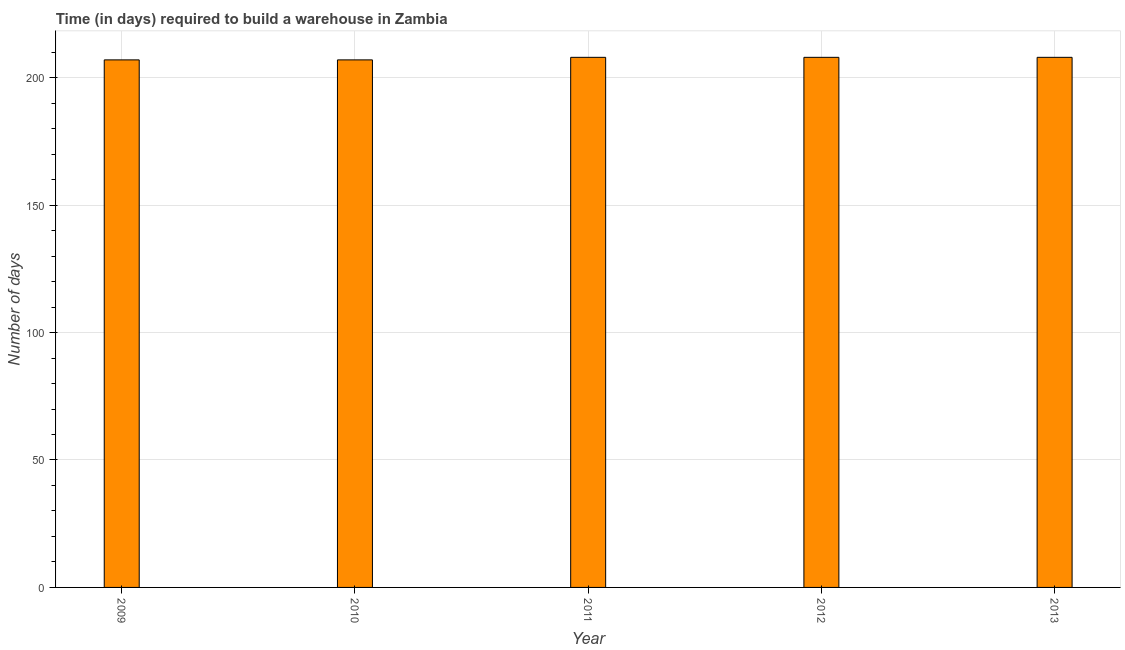What is the title of the graph?
Offer a terse response. Time (in days) required to build a warehouse in Zambia. What is the label or title of the Y-axis?
Your answer should be compact. Number of days. What is the time required to build a warehouse in 2010?
Offer a very short reply. 207. Across all years, what is the maximum time required to build a warehouse?
Keep it short and to the point. 208. Across all years, what is the minimum time required to build a warehouse?
Provide a succinct answer. 207. In which year was the time required to build a warehouse maximum?
Make the answer very short. 2011. What is the sum of the time required to build a warehouse?
Your answer should be very brief. 1038. What is the difference between the time required to build a warehouse in 2009 and 2010?
Provide a short and direct response. 0. What is the average time required to build a warehouse per year?
Provide a short and direct response. 207. What is the median time required to build a warehouse?
Your answer should be compact. 208. Do a majority of the years between 2009 and 2012 (inclusive) have time required to build a warehouse greater than 40 days?
Your response must be concise. Yes. Is the time required to build a warehouse in 2009 less than that in 2013?
Offer a terse response. Yes. Is the difference between the time required to build a warehouse in 2011 and 2013 greater than the difference between any two years?
Your answer should be compact. No. In how many years, is the time required to build a warehouse greater than the average time required to build a warehouse taken over all years?
Provide a succinct answer. 3. How many bars are there?
Offer a terse response. 5. How many years are there in the graph?
Your answer should be very brief. 5. What is the Number of days in 2009?
Offer a very short reply. 207. What is the Number of days in 2010?
Your response must be concise. 207. What is the Number of days of 2011?
Ensure brevity in your answer.  208. What is the Number of days of 2012?
Keep it short and to the point. 208. What is the Number of days of 2013?
Your answer should be very brief. 208. What is the difference between the Number of days in 2009 and 2010?
Your response must be concise. 0. What is the difference between the Number of days in 2009 and 2011?
Ensure brevity in your answer.  -1. What is the difference between the Number of days in 2009 and 2012?
Offer a terse response. -1. What is the difference between the Number of days in 2009 and 2013?
Your response must be concise. -1. What is the difference between the Number of days in 2010 and 2011?
Offer a terse response. -1. What is the difference between the Number of days in 2010 and 2012?
Provide a succinct answer. -1. What is the difference between the Number of days in 2011 and 2012?
Your answer should be compact. 0. What is the ratio of the Number of days in 2009 to that in 2011?
Your answer should be very brief. 0.99. What is the ratio of the Number of days in 2009 to that in 2012?
Give a very brief answer. 0.99. What is the ratio of the Number of days in 2009 to that in 2013?
Your response must be concise. 0.99. What is the ratio of the Number of days in 2010 to that in 2012?
Make the answer very short. 0.99. What is the ratio of the Number of days in 2010 to that in 2013?
Offer a terse response. 0.99. What is the ratio of the Number of days in 2011 to that in 2013?
Ensure brevity in your answer.  1. What is the ratio of the Number of days in 2012 to that in 2013?
Your answer should be compact. 1. 